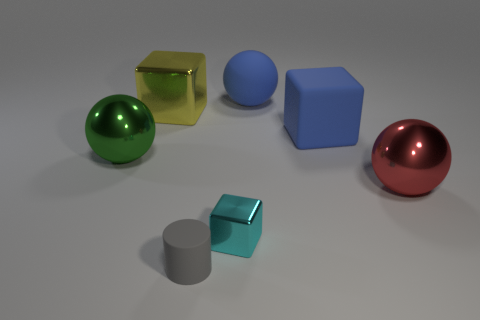The matte thing that is the same color as the rubber block is what shape?
Provide a succinct answer. Sphere. The yellow metallic thing that is the same size as the blue ball is what shape?
Offer a very short reply. Cube. Are there any large matte balls of the same color as the big rubber cube?
Offer a terse response. Yes. What size is the matte cube?
Provide a short and direct response. Large. Do the gray cylinder and the big blue cube have the same material?
Provide a succinct answer. Yes. How many big red shiny spheres are in front of the large blue rubber thing that is in front of the rubber thing that is behind the large yellow thing?
Keep it short and to the point. 1. There is a large metal thing to the right of the rubber ball; what is its shape?
Provide a succinct answer. Sphere. How many other things are made of the same material as the cyan object?
Offer a terse response. 3. Do the matte cube and the matte sphere have the same color?
Your answer should be very brief. Yes. Is the number of yellow metal things that are on the left side of the yellow metallic thing less than the number of large metallic objects that are to the left of the green thing?
Offer a terse response. No. 